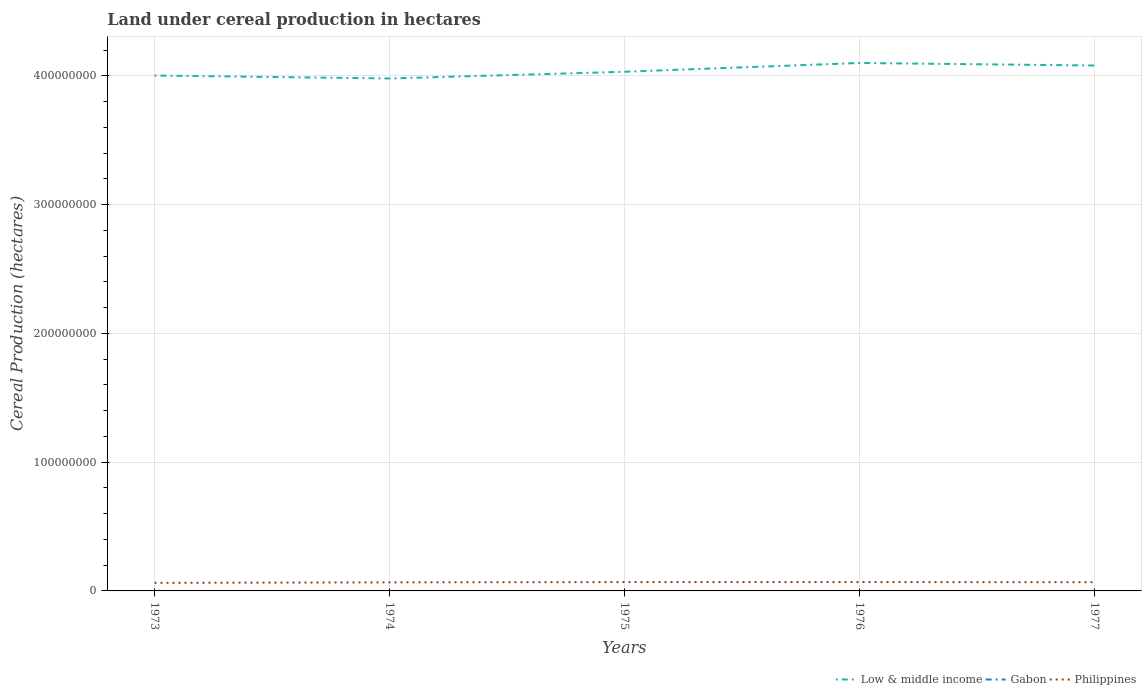How many different coloured lines are there?
Your response must be concise. 3. Does the line corresponding to Low & middle income intersect with the line corresponding to Gabon?
Your answer should be very brief. No. Across all years, what is the maximum land under cereal production in Gabon?
Your response must be concise. 5150. In which year was the land under cereal production in Low & middle income maximum?
Make the answer very short. 1974. What is the total land under cereal production in Gabon in the graph?
Offer a terse response. -850. What is the difference between the highest and the second highest land under cereal production in Gabon?
Offer a terse response. 850. What is the difference between the highest and the lowest land under cereal production in Low & middle income?
Provide a short and direct response. 2. Is the land under cereal production in Gabon strictly greater than the land under cereal production in Low & middle income over the years?
Provide a succinct answer. Yes. What is the difference between two consecutive major ticks on the Y-axis?
Keep it short and to the point. 1.00e+08. Does the graph contain any zero values?
Make the answer very short. No. Does the graph contain grids?
Provide a short and direct response. Yes. Where does the legend appear in the graph?
Ensure brevity in your answer.  Bottom right. How are the legend labels stacked?
Make the answer very short. Horizontal. What is the title of the graph?
Keep it short and to the point. Land under cereal production in hectares. Does "Thailand" appear as one of the legend labels in the graph?
Give a very brief answer. No. What is the label or title of the Y-axis?
Your answer should be compact. Cereal Production (hectares). What is the Cereal Production (hectares) in Low & middle income in 1973?
Your response must be concise. 4.00e+08. What is the Cereal Production (hectares) in Gabon in 1973?
Your answer should be compact. 5150. What is the Cereal Production (hectares) of Philippines in 1973?
Give a very brief answer. 6.26e+06. What is the Cereal Production (hectares) in Low & middle income in 1974?
Make the answer very short. 3.98e+08. What is the Cereal Production (hectares) in Gabon in 1974?
Provide a short and direct response. 5600. What is the Cereal Production (hectares) of Philippines in 1974?
Your answer should be compact. 6.65e+06. What is the Cereal Production (hectares) in Low & middle income in 1975?
Your response must be concise. 4.03e+08. What is the Cereal Production (hectares) of Gabon in 1975?
Offer a terse response. 5550. What is the Cereal Production (hectares) of Philippines in 1975?
Offer a terse response. 6.87e+06. What is the Cereal Production (hectares) in Low & middle income in 1976?
Give a very brief answer. 4.10e+08. What is the Cereal Production (hectares) of Gabon in 1976?
Make the answer very short. 5650. What is the Cereal Production (hectares) in Philippines in 1976?
Keep it short and to the point. 6.89e+06. What is the Cereal Production (hectares) in Low & middle income in 1977?
Offer a very short reply. 4.08e+08. What is the Cereal Production (hectares) of Gabon in 1977?
Provide a short and direct response. 6000. What is the Cereal Production (hectares) of Philippines in 1977?
Your answer should be very brief. 6.78e+06. Across all years, what is the maximum Cereal Production (hectares) in Low & middle income?
Your response must be concise. 4.10e+08. Across all years, what is the maximum Cereal Production (hectares) of Gabon?
Make the answer very short. 6000. Across all years, what is the maximum Cereal Production (hectares) in Philippines?
Ensure brevity in your answer.  6.89e+06. Across all years, what is the minimum Cereal Production (hectares) of Low & middle income?
Ensure brevity in your answer.  3.98e+08. Across all years, what is the minimum Cereal Production (hectares) of Gabon?
Provide a short and direct response. 5150. Across all years, what is the minimum Cereal Production (hectares) in Philippines?
Offer a terse response. 6.26e+06. What is the total Cereal Production (hectares) of Low & middle income in the graph?
Provide a short and direct response. 2.02e+09. What is the total Cereal Production (hectares) in Gabon in the graph?
Offer a very short reply. 2.80e+04. What is the total Cereal Production (hectares) in Philippines in the graph?
Offer a very short reply. 3.34e+07. What is the difference between the Cereal Production (hectares) of Low & middle income in 1973 and that in 1974?
Provide a short and direct response. 2.28e+06. What is the difference between the Cereal Production (hectares) of Gabon in 1973 and that in 1974?
Give a very brief answer. -450. What is the difference between the Cereal Production (hectares) in Philippines in 1973 and that in 1974?
Ensure brevity in your answer.  -3.94e+05. What is the difference between the Cereal Production (hectares) in Low & middle income in 1973 and that in 1975?
Your answer should be compact. -2.93e+06. What is the difference between the Cereal Production (hectares) of Gabon in 1973 and that in 1975?
Provide a succinct answer. -400. What is the difference between the Cereal Production (hectares) in Philippines in 1973 and that in 1975?
Your answer should be compact. -6.14e+05. What is the difference between the Cereal Production (hectares) of Low & middle income in 1973 and that in 1976?
Your response must be concise. -9.76e+06. What is the difference between the Cereal Production (hectares) of Gabon in 1973 and that in 1976?
Provide a succinct answer. -500. What is the difference between the Cereal Production (hectares) in Philippines in 1973 and that in 1976?
Give a very brief answer. -6.32e+05. What is the difference between the Cereal Production (hectares) in Low & middle income in 1973 and that in 1977?
Make the answer very short. -7.78e+06. What is the difference between the Cereal Production (hectares) in Gabon in 1973 and that in 1977?
Your answer should be very brief. -850. What is the difference between the Cereal Production (hectares) in Philippines in 1973 and that in 1977?
Give a very brief answer. -5.18e+05. What is the difference between the Cereal Production (hectares) in Low & middle income in 1974 and that in 1975?
Your answer should be very brief. -5.21e+06. What is the difference between the Cereal Production (hectares) of Gabon in 1974 and that in 1975?
Ensure brevity in your answer.  50. What is the difference between the Cereal Production (hectares) of Philippines in 1974 and that in 1975?
Offer a very short reply. -2.20e+05. What is the difference between the Cereal Production (hectares) in Low & middle income in 1974 and that in 1976?
Offer a terse response. -1.20e+07. What is the difference between the Cereal Production (hectares) of Gabon in 1974 and that in 1976?
Offer a terse response. -50. What is the difference between the Cereal Production (hectares) in Philippines in 1974 and that in 1976?
Your response must be concise. -2.38e+05. What is the difference between the Cereal Production (hectares) of Low & middle income in 1974 and that in 1977?
Offer a terse response. -1.01e+07. What is the difference between the Cereal Production (hectares) of Gabon in 1974 and that in 1977?
Give a very brief answer. -400. What is the difference between the Cereal Production (hectares) in Philippines in 1974 and that in 1977?
Offer a very short reply. -1.24e+05. What is the difference between the Cereal Production (hectares) of Low & middle income in 1975 and that in 1976?
Offer a very short reply. -6.83e+06. What is the difference between the Cereal Production (hectares) of Gabon in 1975 and that in 1976?
Give a very brief answer. -100. What is the difference between the Cereal Production (hectares) in Philippines in 1975 and that in 1976?
Your response must be concise. -1.83e+04. What is the difference between the Cereal Production (hectares) in Low & middle income in 1975 and that in 1977?
Give a very brief answer. -4.86e+06. What is the difference between the Cereal Production (hectares) of Gabon in 1975 and that in 1977?
Keep it short and to the point. -450. What is the difference between the Cereal Production (hectares) of Philippines in 1975 and that in 1977?
Provide a short and direct response. 9.58e+04. What is the difference between the Cereal Production (hectares) of Low & middle income in 1976 and that in 1977?
Offer a very short reply. 1.97e+06. What is the difference between the Cereal Production (hectares) of Gabon in 1976 and that in 1977?
Offer a very short reply. -350. What is the difference between the Cereal Production (hectares) in Philippines in 1976 and that in 1977?
Your response must be concise. 1.14e+05. What is the difference between the Cereal Production (hectares) in Low & middle income in 1973 and the Cereal Production (hectares) in Gabon in 1974?
Give a very brief answer. 4.00e+08. What is the difference between the Cereal Production (hectares) of Low & middle income in 1973 and the Cereal Production (hectares) of Philippines in 1974?
Make the answer very short. 3.94e+08. What is the difference between the Cereal Production (hectares) in Gabon in 1973 and the Cereal Production (hectares) in Philippines in 1974?
Ensure brevity in your answer.  -6.65e+06. What is the difference between the Cereal Production (hectares) in Low & middle income in 1973 and the Cereal Production (hectares) in Gabon in 1975?
Your answer should be very brief. 4.00e+08. What is the difference between the Cereal Production (hectares) in Low & middle income in 1973 and the Cereal Production (hectares) in Philippines in 1975?
Provide a succinct answer. 3.93e+08. What is the difference between the Cereal Production (hectares) of Gabon in 1973 and the Cereal Production (hectares) of Philippines in 1975?
Your answer should be compact. -6.87e+06. What is the difference between the Cereal Production (hectares) of Low & middle income in 1973 and the Cereal Production (hectares) of Gabon in 1976?
Offer a very short reply. 4.00e+08. What is the difference between the Cereal Production (hectares) of Low & middle income in 1973 and the Cereal Production (hectares) of Philippines in 1976?
Give a very brief answer. 3.93e+08. What is the difference between the Cereal Production (hectares) of Gabon in 1973 and the Cereal Production (hectares) of Philippines in 1976?
Offer a terse response. -6.88e+06. What is the difference between the Cereal Production (hectares) in Low & middle income in 1973 and the Cereal Production (hectares) in Gabon in 1977?
Your answer should be compact. 4.00e+08. What is the difference between the Cereal Production (hectares) of Low & middle income in 1973 and the Cereal Production (hectares) of Philippines in 1977?
Provide a short and direct response. 3.94e+08. What is the difference between the Cereal Production (hectares) of Gabon in 1973 and the Cereal Production (hectares) of Philippines in 1977?
Your response must be concise. -6.77e+06. What is the difference between the Cereal Production (hectares) in Low & middle income in 1974 and the Cereal Production (hectares) in Gabon in 1975?
Keep it short and to the point. 3.98e+08. What is the difference between the Cereal Production (hectares) of Low & middle income in 1974 and the Cereal Production (hectares) of Philippines in 1975?
Ensure brevity in your answer.  3.91e+08. What is the difference between the Cereal Production (hectares) in Gabon in 1974 and the Cereal Production (hectares) in Philippines in 1975?
Provide a succinct answer. -6.87e+06. What is the difference between the Cereal Production (hectares) of Low & middle income in 1974 and the Cereal Production (hectares) of Gabon in 1976?
Provide a short and direct response. 3.98e+08. What is the difference between the Cereal Production (hectares) in Low & middle income in 1974 and the Cereal Production (hectares) in Philippines in 1976?
Offer a terse response. 3.91e+08. What is the difference between the Cereal Production (hectares) of Gabon in 1974 and the Cereal Production (hectares) of Philippines in 1976?
Your response must be concise. -6.88e+06. What is the difference between the Cereal Production (hectares) of Low & middle income in 1974 and the Cereal Production (hectares) of Gabon in 1977?
Provide a succinct answer. 3.98e+08. What is the difference between the Cereal Production (hectares) of Low & middle income in 1974 and the Cereal Production (hectares) of Philippines in 1977?
Your answer should be very brief. 3.91e+08. What is the difference between the Cereal Production (hectares) in Gabon in 1974 and the Cereal Production (hectares) in Philippines in 1977?
Your answer should be compact. -6.77e+06. What is the difference between the Cereal Production (hectares) in Low & middle income in 1975 and the Cereal Production (hectares) in Gabon in 1976?
Keep it short and to the point. 4.03e+08. What is the difference between the Cereal Production (hectares) of Low & middle income in 1975 and the Cereal Production (hectares) of Philippines in 1976?
Offer a very short reply. 3.96e+08. What is the difference between the Cereal Production (hectares) in Gabon in 1975 and the Cereal Production (hectares) in Philippines in 1976?
Your answer should be compact. -6.88e+06. What is the difference between the Cereal Production (hectares) of Low & middle income in 1975 and the Cereal Production (hectares) of Gabon in 1977?
Give a very brief answer. 4.03e+08. What is the difference between the Cereal Production (hectares) of Low & middle income in 1975 and the Cereal Production (hectares) of Philippines in 1977?
Your response must be concise. 3.96e+08. What is the difference between the Cereal Production (hectares) in Gabon in 1975 and the Cereal Production (hectares) in Philippines in 1977?
Make the answer very short. -6.77e+06. What is the difference between the Cereal Production (hectares) in Low & middle income in 1976 and the Cereal Production (hectares) in Gabon in 1977?
Your answer should be very brief. 4.10e+08. What is the difference between the Cereal Production (hectares) of Low & middle income in 1976 and the Cereal Production (hectares) of Philippines in 1977?
Provide a short and direct response. 4.03e+08. What is the difference between the Cereal Production (hectares) in Gabon in 1976 and the Cereal Production (hectares) in Philippines in 1977?
Make the answer very short. -6.77e+06. What is the average Cereal Production (hectares) in Low & middle income per year?
Give a very brief answer. 4.04e+08. What is the average Cereal Production (hectares) of Gabon per year?
Your response must be concise. 5590. What is the average Cereal Production (hectares) of Philippines per year?
Your response must be concise. 6.69e+06. In the year 1973, what is the difference between the Cereal Production (hectares) of Low & middle income and Cereal Production (hectares) of Gabon?
Offer a terse response. 4.00e+08. In the year 1973, what is the difference between the Cereal Production (hectares) of Low & middle income and Cereal Production (hectares) of Philippines?
Offer a terse response. 3.94e+08. In the year 1973, what is the difference between the Cereal Production (hectares) in Gabon and Cereal Production (hectares) in Philippines?
Provide a short and direct response. -6.25e+06. In the year 1974, what is the difference between the Cereal Production (hectares) of Low & middle income and Cereal Production (hectares) of Gabon?
Your answer should be compact. 3.98e+08. In the year 1974, what is the difference between the Cereal Production (hectares) of Low & middle income and Cereal Production (hectares) of Philippines?
Keep it short and to the point. 3.91e+08. In the year 1974, what is the difference between the Cereal Production (hectares) in Gabon and Cereal Production (hectares) in Philippines?
Provide a succinct answer. -6.65e+06. In the year 1975, what is the difference between the Cereal Production (hectares) of Low & middle income and Cereal Production (hectares) of Gabon?
Provide a succinct answer. 4.03e+08. In the year 1975, what is the difference between the Cereal Production (hectares) of Low & middle income and Cereal Production (hectares) of Philippines?
Your response must be concise. 3.96e+08. In the year 1975, what is the difference between the Cereal Production (hectares) in Gabon and Cereal Production (hectares) in Philippines?
Offer a very short reply. -6.87e+06. In the year 1976, what is the difference between the Cereal Production (hectares) of Low & middle income and Cereal Production (hectares) of Gabon?
Your response must be concise. 4.10e+08. In the year 1976, what is the difference between the Cereal Production (hectares) of Low & middle income and Cereal Production (hectares) of Philippines?
Ensure brevity in your answer.  4.03e+08. In the year 1976, what is the difference between the Cereal Production (hectares) of Gabon and Cereal Production (hectares) of Philippines?
Your answer should be very brief. -6.88e+06. In the year 1977, what is the difference between the Cereal Production (hectares) of Low & middle income and Cereal Production (hectares) of Gabon?
Offer a terse response. 4.08e+08. In the year 1977, what is the difference between the Cereal Production (hectares) in Low & middle income and Cereal Production (hectares) in Philippines?
Offer a terse response. 4.01e+08. In the year 1977, what is the difference between the Cereal Production (hectares) of Gabon and Cereal Production (hectares) of Philippines?
Your answer should be very brief. -6.77e+06. What is the ratio of the Cereal Production (hectares) in Gabon in 1973 to that in 1974?
Your response must be concise. 0.92. What is the ratio of the Cereal Production (hectares) in Philippines in 1973 to that in 1974?
Ensure brevity in your answer.  0.94. What is the ratio of the Cereal Production (hectares) in Gabon in 1973 to that in 1975?
Offer a very short reply. 0.93. What is the ratio of the Cereal Production (hectares) of Philippines in 1973 to that in 1975?
Give a very brief answer. 0.91. What is the ratio of the Cereal Production (hectares) in Low & middle income in 1973 to that in 1976?
Keep it short and to the point. 0.98. What is the ratio of the Cereal Production (hectares) in Gabon in 1973 to that in 1976?
Ensure brevity in your answer.  0.91. What is the ratio of the Cereal Production (hectares) of Philippines in 1973 to that in 1976?
Provide a short and direct response. 0.91. What is the ratio of the Cereal Production (hectares) of Low & middle income in 1973 to that in 1977?
Your response must be concise. 0.98. What is the ratio of the Cereal Production (hectares) in Gabon in 1973 to that in 1977?
Give a very brief answer. 0.86. What is the ratio of the Cereal Production (hectares) of Philippines in 1973 to that in 1977?
Your response must be concise. 0.92. What is the ratio of the Cereal Production (hectares) of Low & middle income in 1974 to that in 1975?
Provide a succinct answer. 0.99. What is the ratio of the Cereal Production (hectares) of Philippines in 1974 to that in 1975?
Make the answer very short. 0.97. What is the ratio of the Cereal Production (hectares) of Low & middle income in 1974 to that in 1976?
Your response must be concise. 0.97. What is the ratio of the Cereal Production (hectares) of Philippines in 1974 to that in 1976?
Your answer should be compact. 0.97. What is the ratio of the Cereal Production (hectares) in Low & middle income in 1974 to that in 1977?
Your response must be concise. 0.98. What is the ratio of the Cereal Production (hectares) of Gabon in 1974 to that in 1977?
Offer a very short reply. 0.93. What is the ratio of the Cereal Production (hectares) in Philippines in 1974 to that in 1977?
Your response must be concise. 0.98. What is the ratio of the Cereal Production (hectares) in Low & middle income in 1975 to that in 1976?
Provide a short and direct response. 0.98. What is the ratio of the Cereal Production (hectares) of Gabon in 1975 to that in 1976?
Provide a short and direct response. 0.98. What is the ratio of the Cereal Production (hectares) of Gabon in 1975 to that in 1977?
Your answer should be very brief. 0.93. What is the ratio of the Cereal Production (hectares) of Philippines in 1975 to that in 1977?
Provide a succinct answer. 1.01. What is the ratio of the Cereal Production (hectares) of Gabon in 1976 to that in 1977?
Ensure brevity in your answer.  0.94. What is the ratio of the Cereal Production (hectares) of Philippines in 1976 to that in 1977?
Offer a very short reply. 1.02. What is the difference between the highest and the second highest Cereal Production (hectares) of Low & middle income?
Make the answer very short. 1.97e+06. What is the difference between the highest and the second highest Cereal Production (hectares) in Gabon?
Offer a terse response. 350. What is the difference between the highest and the second highest Cereal Production (hectares) in Philippines?
Ensure brevity in your answer.  1.83e+04. What is the difference between the highest and the lowest Cereal Production (hectares) in Low & middle income?
Give a very brief answer. 1.20e+07. What is the difference between the highest and the lowest Cereal Production (hectares) in Gabon?
Give a very brief answer. 850. What is the difference between the highest and the lowest Cereal Production (hectares) in Philippines?
Your response must be concise. 6.32e+05. 